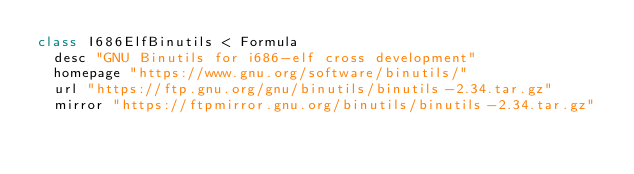Convert code to text. <code><loc_0><loc_0><loc_500><loc_500><_Ruby_>class I686ElfBinutils < Formula
  desc "GNU Binutils for i686-elf cross development"
  homepage "https://www.gnu.org/software/binutils/"
  url "https://ftp.gnu.org/gnu/binutils/binutils-2.34.tar.gz"
  mirror "https://ftpmirror.gnu.org/binutils/binutils-2.34.tar.gz"</code> 